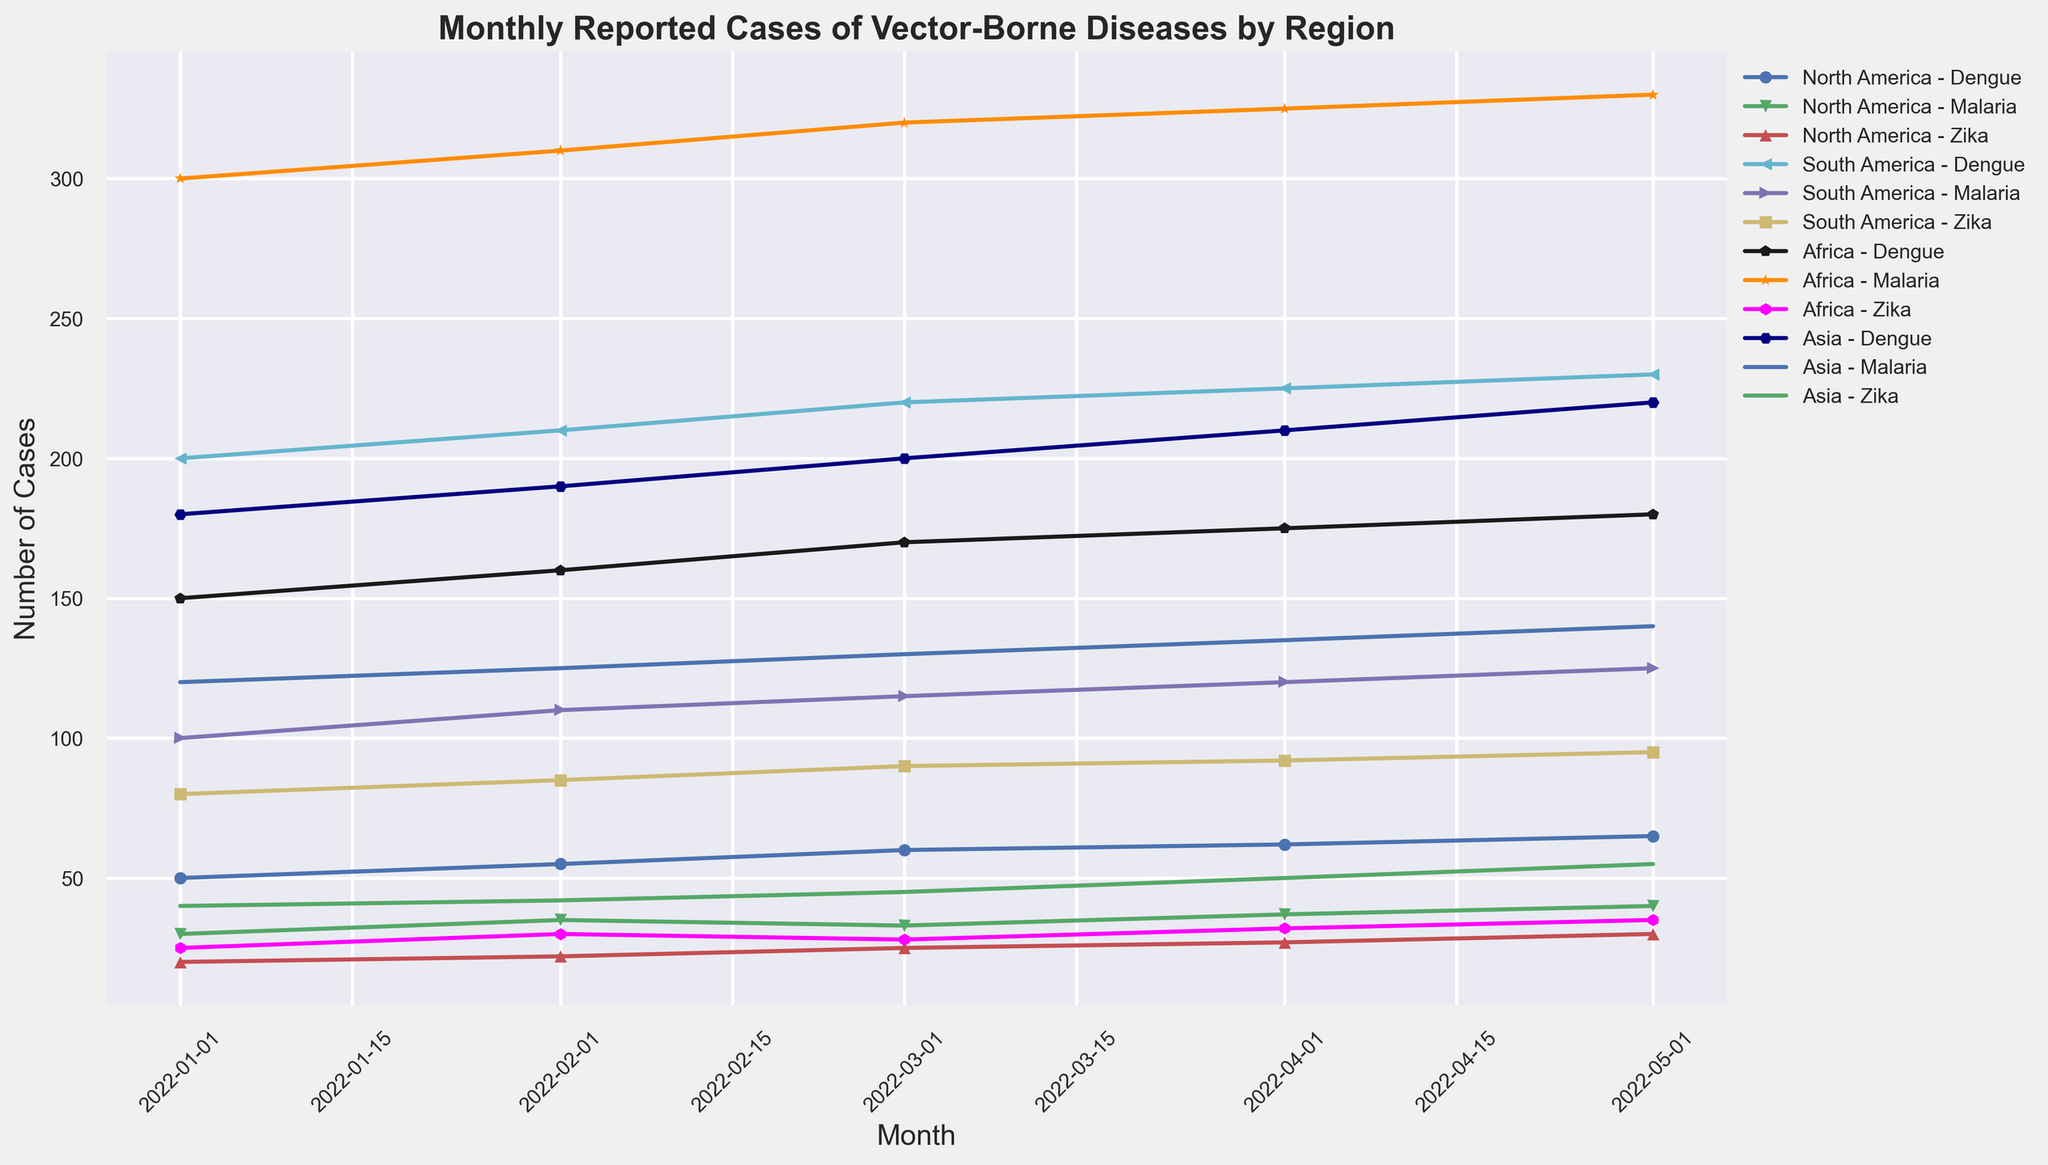Which region has the highest number of Malaria cases in May 2022? Look for the Malaria cases in each region for May 2022. North America has 40, South America has 125, Africa has 330, and Asia has 140. The highest is in Africa.
Answer: Africa Between January and May 2022, which vector-borne disease in Asia had the largest increase in reported cases? Calculate the difference in cases for each disease in Asia between January and May 2022. Dengue: 220 - 180 = 40, Malaria: 140 - 120 = 20, Zika: 55 - 40 = 15. The largest increase is for Dengue (40).
Answer: Dengue In April 2022, did North America have more Dengue or Malaria cases? Compare the Dengue and Malaria cases in North America for April 2022. Dengue has 62 cases, whereas Malaria has 37 cases. Dengue cases are higher.
Answer: Dengue What is the average number of Zika cases reported in South America from January to May 2022? Sum up the Zika cases in South America for each month from January to May 2022 and divide by the number of months. (80 + 85 + 90 + 92 + 95) / 5 = 88.4
Answer: 88.4 Which month in 2022 had the highest total cases of vector-borne diseases across all regions? Calculate the total cases for each month by adding up all cases of Dengue, Malaria, and Zika across all regions. Identify the month with the highest total. January: (50 + 30 + 20 + 200 + 100 + 80 + 150 + 300 + 25 + 180 + 120 + 40) = 1295, February: (55 + 35 + 22 + 210 + 110 + 85 + 160 + 310 + 30 + 190 + 125 + 42) = 1374, March: (60 + 33 + 25 + 220 + 115 + 90 + 170 + 320 + 28 + 200 + 130 + 45) = 1436, April: (62 + 37 + 27 + 225 + 120 + 92 + 175 + 325 + 32 + 210 + 135 + 50) = 1490, May: (65 + 40 + 30 + 230 + 125 + 95 + 180 + 330 + 35 + 220 + 140 + 55) = 1545. The highest total is in May 2022.
Answer: May 2022 In February 2022, which vector-borne disease had the lowest number of cases in Africa? Compare the number of cases for Dengue, Malaria, and Zika in Africa for February 2022. Dengue has 160, Malaria has 310, and Zika has 30. Zika has the lowest number of cases.
Answer: Zika How do the total number of Dengue cases in May 2022 compare between Asia and South America? Identify the Dengue cases for May 2022 in Asia (220) and South America (230). Compare the numbers; Asia has fewer cases compared to South America.
Answer: South America has more Which vector-borne disease in North America showed a consistent increase in cases from January to May 2022? Analyze the trend of cases for Dengue, Malaria, and Zika in North America from January to May 2022. Dengue: 50, 55, 60, 62, 65 (increasing), Malaria: 30, 35, 33, 37, 40 (fluctuating), Zika: 20, 22, 25, 27, 30 (increasing). Both Dengue and Zika showed a consistent increase, but Dengue started higher.
Answer: Dengue Which vector-borne disease had the least variation in reported cases across all regions from January to May 2022? Determine the range (max-min) for each disease across all regions over the months. Dengue: (230 - 50) = 180, Malaria: (330 - 30) = 300, Zika: (95 - 20) = 75. The least variation is in Zika.
Answer: Zika 